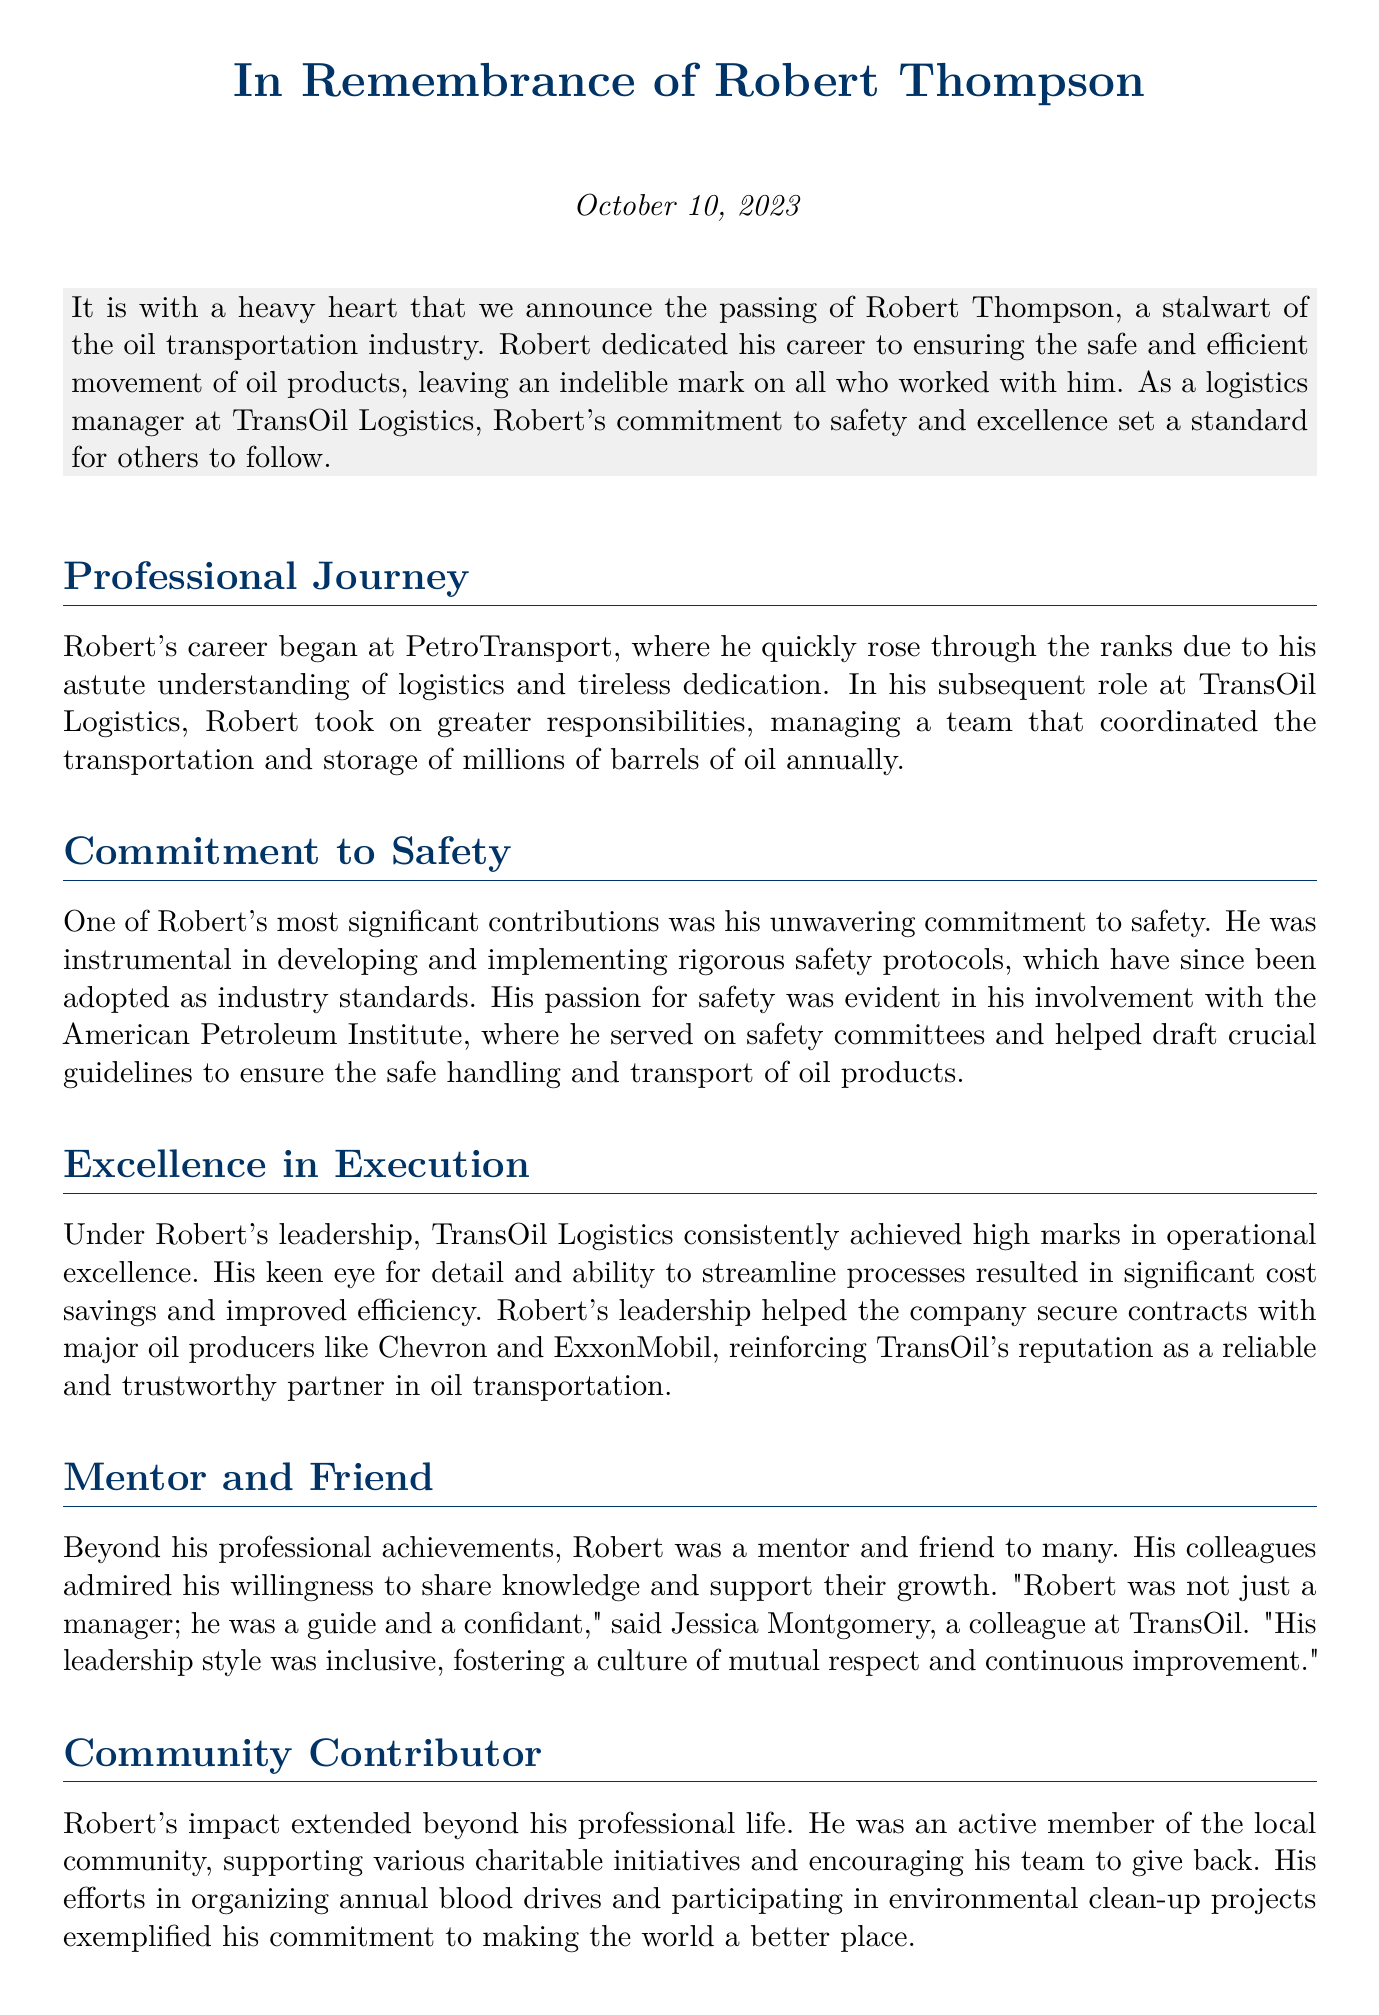What is the full name of the individual being remembered? The document mentions Robert's full name as Robert Thompson.
Answer: Robert Thompson When did Robert Thompson pass away? The date of Robert's passing is stated as October 10, 2023.
Answer: October 10, 2023 What company did Robert manage at the time of his passing? The document lists TransOil Logistics as the company where Robert served as a logistics manager.
Answer: TransOil Logistics What was one of Robert's significant contributions to the oil transportation industry? The document highlights his role in developing and implementing rigorous safety protocols.
Answer: Safety protocols Who quoted Robert as more than just a manager? Jessica Montgomery is noted as a colleague who referred to Robert in this way.
Answer: Jessica Montgomery What major oil companies did TransOil Logistics secure contracts with under Robert's leadership? The document states that contracts were secured with Chevron and ExxonMobil.
Answer: Chevron and ExxonMobil How did Robert contribute to his local community? He was involved in organizing annual blood drives and participating in environmental clean-up projects.
Answer: Blood drives and clean-up projects What qualities did Robert display as a mentor? He is described as a guide and a confidant by his colleagues, emphasizing his supportive nature.
Answer: Guide and confidant What is the primary theme of Robert's legacy according to the document? The document mentions his legacy as one of unwavering dedication to safety, excellence, and community service.
Answer: Safety, excellence, and community service 